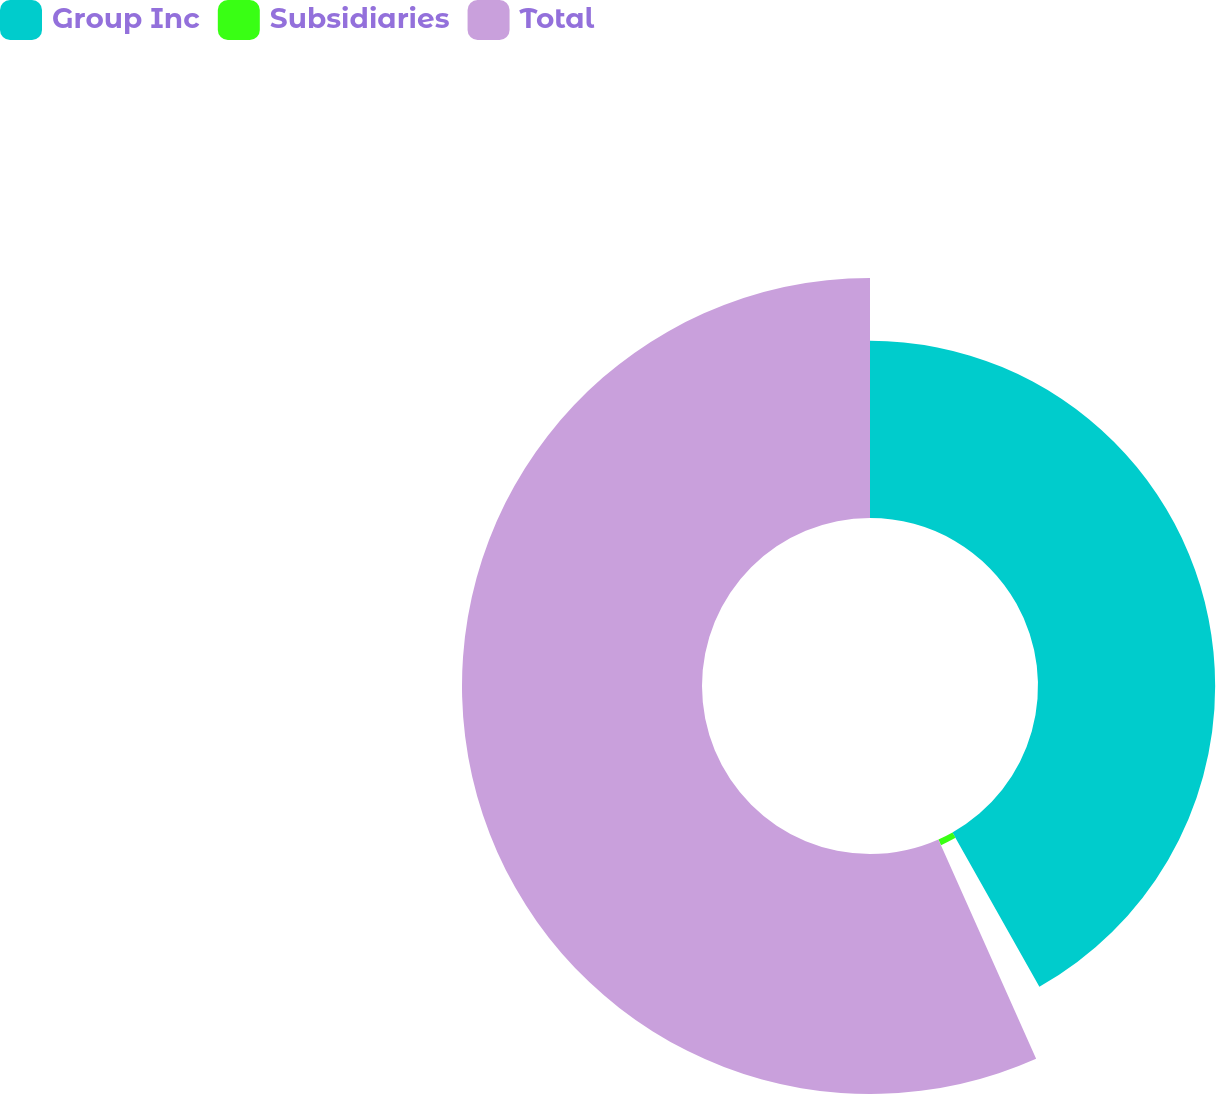Convert chart to OTSL. <chart><loc_0><loc_0><loc_500><loc_500><pie_chart><fcel>Group Inc<fcel>Subsidiaries<fcel>Total<nl><fcel>41.84%<fcel>1.49%<fcel>56.68%<nl></chart> 